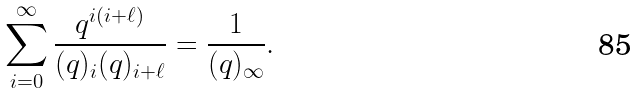Convert formula to latex. <formula><loc_0><loc_0><loc_500><loc_500>\sum _ { i = 0 } ^ { \infty } \frac { q ^ { i ( i + \ell ) } } { ( q ) _ { i } ( q ) _ { i + \ell } } = \frac { 1 } { ( q ) _ { \infty } } .</formula> 